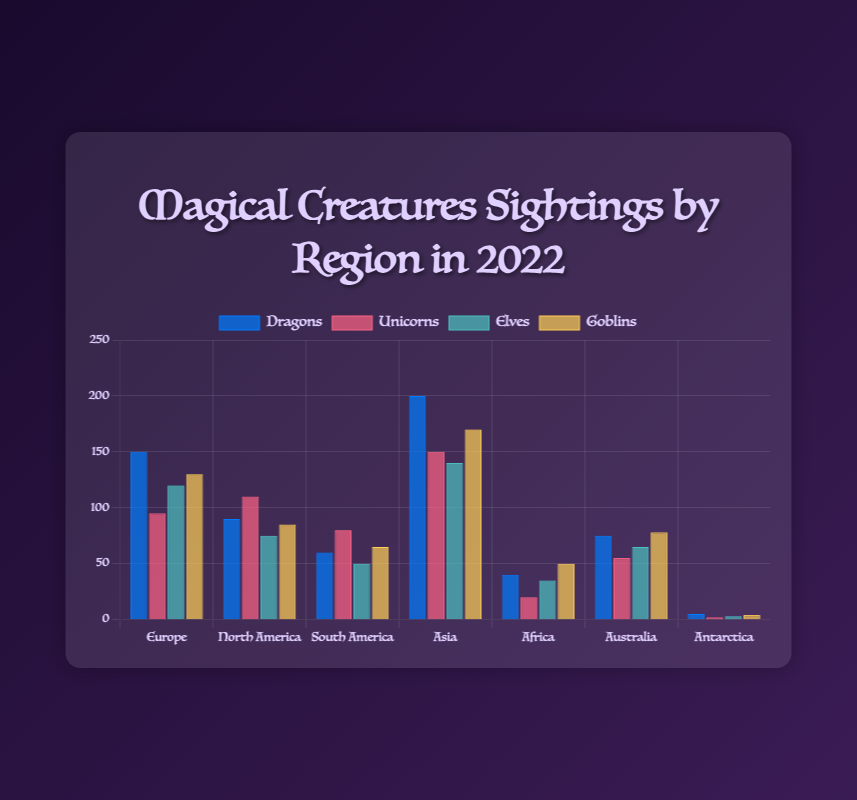Which region had the highest number of dragon sightings in 2022? The tallest blue bar in the chart represents the region with the highest number of dragon sightings. Asia has the tallest blue bar, indicating it had the highest number of dragon sightings.
Answer: Asia By how many more sightings did Europe surpass South America in terms of elves? To find this, we subtract the number of elf sightings in South America from the number in Europe. Europe had 120 elf sightings and South America had 50, so 120 - 50 = 70.
Answer: 70 Which creature had the least number of sightings in Antarctica? The shortest bar for Antarctica will indicate the creature with the least sightings. The bar representing unicorns (red) is the shortest in Antarctica.
Answer: Unicorns What is the total number of goblin sightings across all regions? To find this, we add the number of goblin sightings from all regions: 130 (Europe) + 85 (North America) + 65 (South America) + 170 (Asia) + 50 (Africa) + 78 (Australia) + 4 (Antarctica) = 582.
Answer: 582 Which region had the highest combined sightings of dragons and unicorns? We need to add dragon and unicorn sightings for each region and compare sums. Europe: 150+95=245, North America: 90+110=200, South America: 60+80=140, Asia: 200+150=350, Africa: 40+20=60, Australia: 75+55=130, Antarctica: 5+2=7. Asia, with 350, had the highest combined sightings.
Answer: Asia How does the number of goblin sightings in Africa compare to those in Australia? We look at the heights of the yellow bars for Africa and Australia. Africa has 50 goblin sightings while Australia has 78. Therefore, Australia has more goblin sightings than Africa.
Answer: Australia What is the total number of magical creature sightings (all types) in North America? Add all creature sightings in North America: 90 (Dragons) + 110 (Unicorns) + 75 (Elves) + 85 (Goblins) = 360.
Answer: 360 How does the number of elf sightings in Africa compare to those in South America? We look at the heights of the green bars for Africa and South America. Africa had 35 elf sightings, while South America had 50. Therefore, South America had more elf sightings than Africa.
Answer: South America In which region were unicorns sighted more frequently than dragons? We need to compare sightings of unicorns and dragons in each region. In North America, unicorn sightings (110) are higher than dragon sightings (90).
Answer: North America What is the average number of dragon sightings per region? Sum all dragon sightings and divide by the number of regions: (150 + 90 + 60 + 200 + 40 + 75 + 5) / 7 = 620 / 7 ≈ 88.57.
Answer: 88.57 